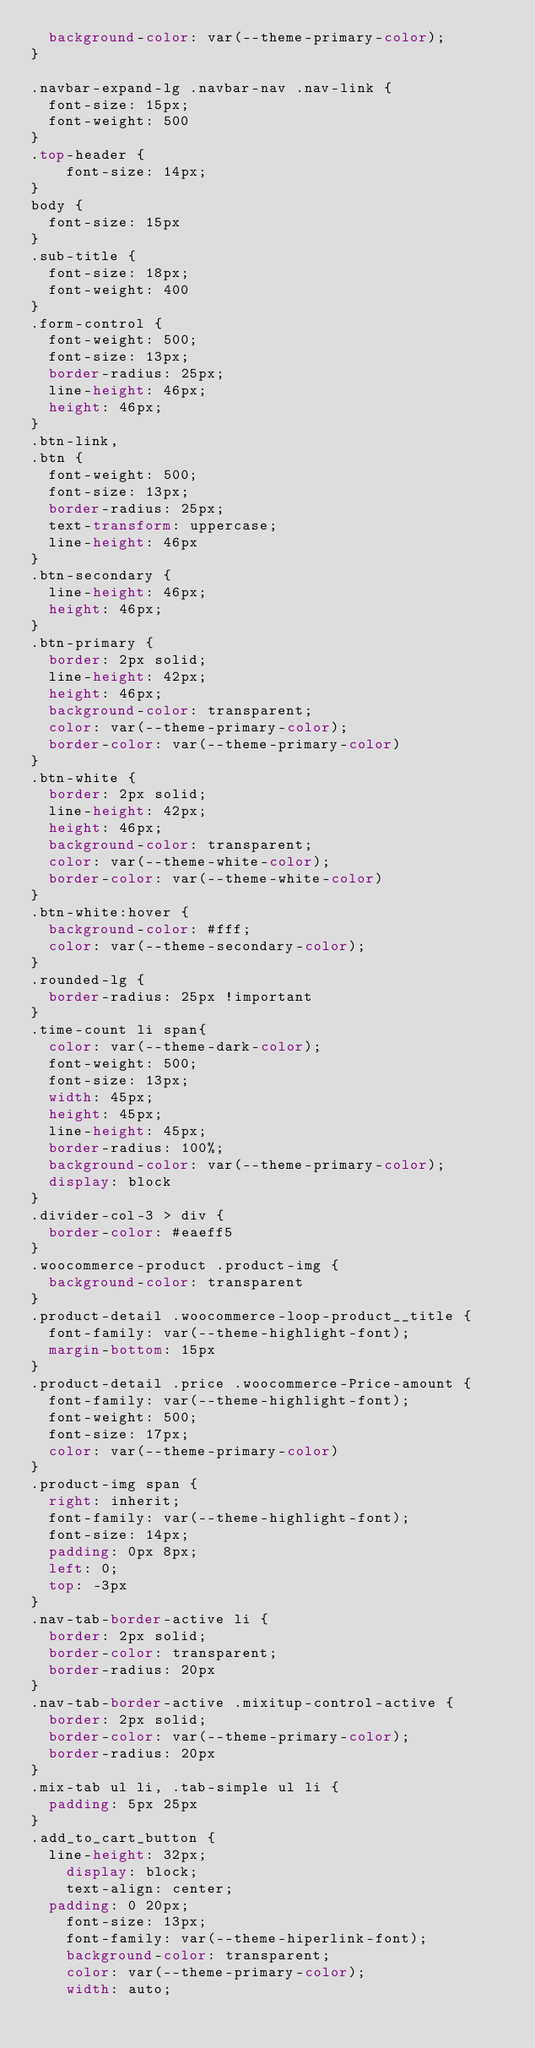Convert code to text. <code><loc_0><loc_0><loc_500><loc_500><_CSS_>	background-color: var(--theme-primary-color);
}

.navbar-expand-lg .navbar-nav .nav-link {
	font-size: 15px;
	font-weight: 500
}
.top-header {
    font-size: 14px;
}
body {
	font-size: 15px
}
.sub-title {
	font-size: 18px;
	font-weight: 400
}
.form-control {
	font-weight: 500;
	font-size: 13px;
	border-radius: 25px;
	line-height: 46px;
	height: 46px;
}
.btn-link,
.btn {
	font-weight: 500;
	font-size: 13px;
	border-radius: 25px;
	text-transform: uppercase;
	line-height: 46px
}
.btn-secondary {
	line-height: 46px;
	height: 46px;
}
.btn-primary {
	border: 2px solid;
	line-height: 42px;
	height: 46px;
	background-color: transparent;
	color: var(--theme-primary-color);
	border-color: var(--theme-primary-color)
}
.btn-white {
	border: 2px solid;
	line-height: 42px;
	height: 46px;
	background-color: transparent;
	color: var(--theme-white-color);
	border-color: var(--theme-white-color)
}
.btn-white:hover {
	background-color: #fff;
	color: var(--theme-secondary-color);
}
.rounded-lg {
	border-radius: 25px !important
}
.time-count li span{
	color: var(--theme-dark-color);
	font-weight: 500;
	font-size: 13px;
	width: 45px;
	height: 45px;
	line-height: 45px;
	border-radius: 100%;
	background-color: var(--theme-primary-color);
	display: block
}
.divider-col-3 > div {
	border-color: #eaeff5
}
.woocommerce-product .product-img {
	background-color: transparent
}
.product-detail .woocommerce-loop-product__title {
	font-family: var(--theme-highlight-font);
	margin-bottom: 15px
}
.product-detail .price .woocommerce-Price-amount {
	font-family: var(--theme-highlight-font);
	font-weight: 500;
	font-size: 17px;
	color: var(--theme-primary-color)
}
.product-img span {
	right: inherit;
	font-family: var(--theme-highlight-font);
	font-size: 14px;
	padding: 0px 8px;
	left: 0;
	top: -3px
}
.nav-tab-border-active li {
	border: 2px solid;
	border-color: transparent;
	border-radius: 20px
}
.nav-tab-border-active .mixitup-control-active {
	border: 2px solid;
	border-color: var(--theme-primary-color);
	border-radius: 20px
}
.mix-tab ul li, .tab-simple ul li {
	padding: 5px 25px
}
.add_to_cart_button {
	line-height: 32px;
    display: block;
    text-align: center;
	padding: 0 20px;
    font-size: 13px;
    font-family: var(--theme-hiperlink-font);
    background-color: transparent;
    color: var(--theme-primary-color);
    width: auto;</code> 